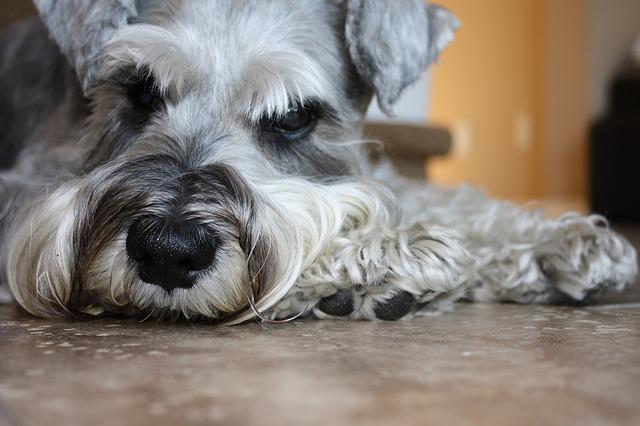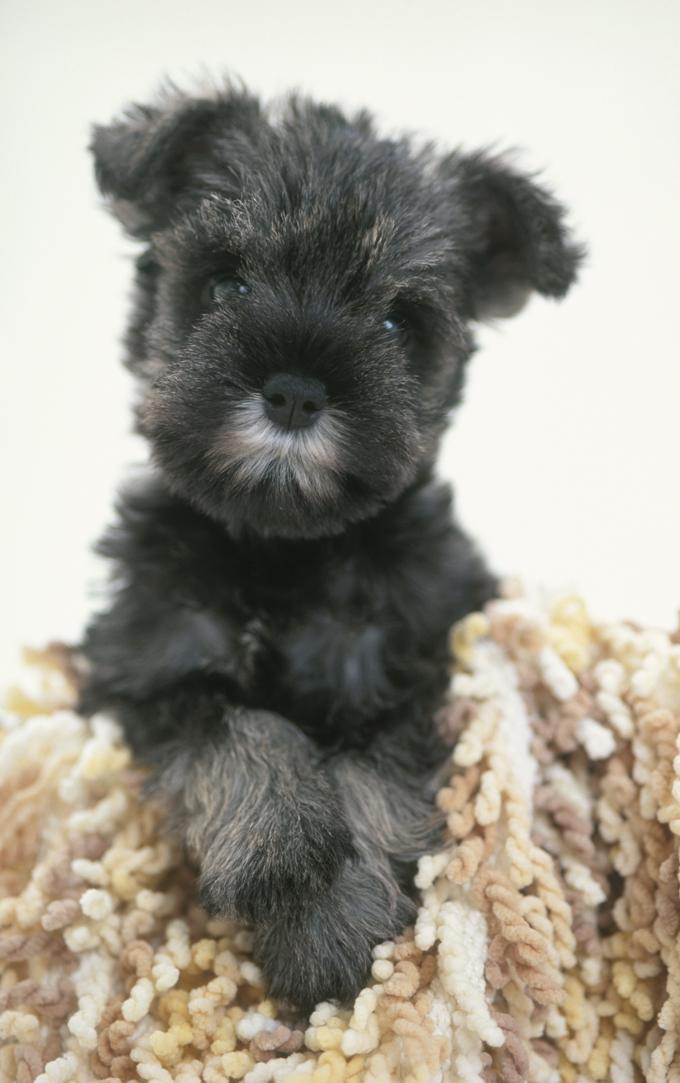The first image is the image on the left, the second image is the image on the right. Assess this claim about the two images: "A dog is chewing on something in one of the photos.". Correct or not? Answer yes or no. No. The first image is the image on the left, the second image is the image on the right. Given the left and right images, does the statement "In one of the images there is a dog chewing a dog bone." hold true? Answer yes or no. No. 